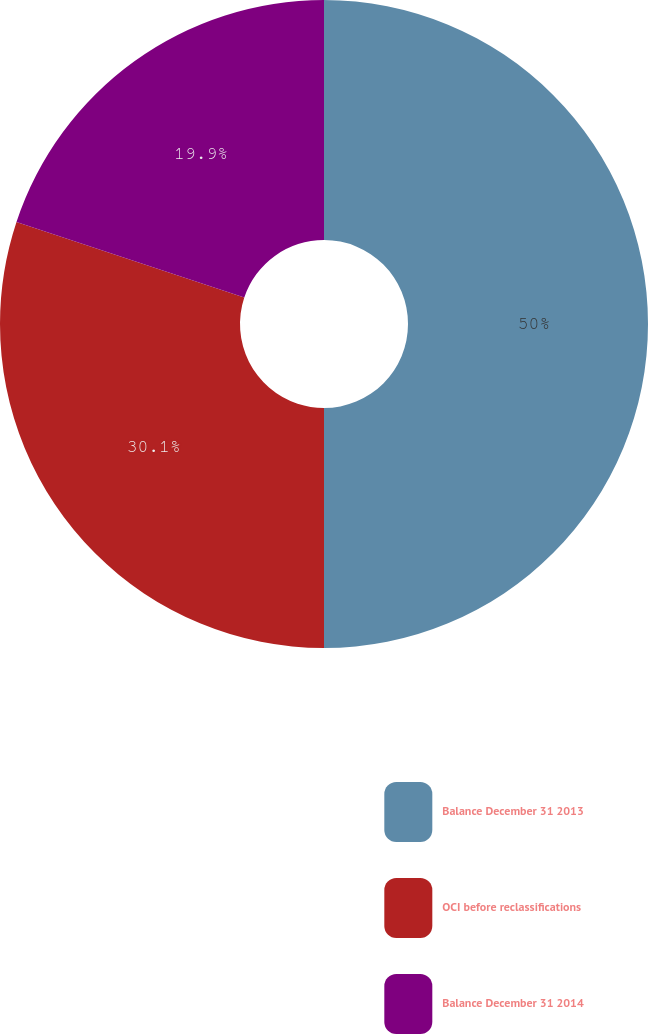Convert chart. <chart><loc_0><loc_0><loc_500><loc_500><pie_chart><fcel>Balance December 31 2013<fcel>OCI before reclassifications<fcel>Balance December 31 2014<nl><fcel>50.0%<fcel>30.1%<fcel>19.9%<nl></chart> 